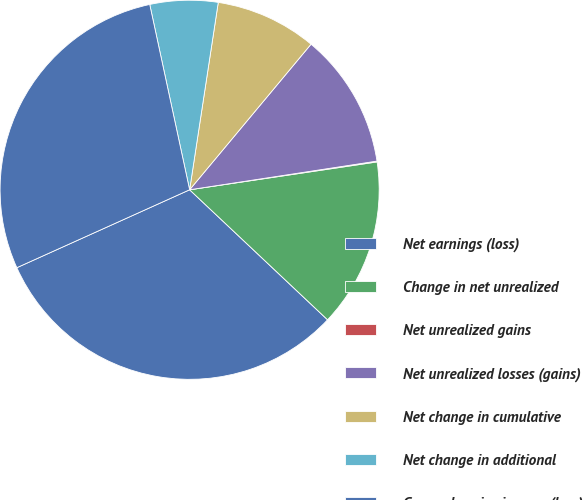Convert chart. <chart><loc_0><loc_0><loc_500><loc_500><pie_chart><fcel>Net earnings (loss)<fcel>Change in net unrealized<fcel>Net unrealized gains<fcel>Net unrealized losses (gains)<fcel>Net change in cumulative<fcel>Net change in additional<fcel>Comprehensive income (loss)<nl><fcel>31.23%<fcel>14.38%<fcel>0.07%<fcel>11.52%<fcel>8.65%<fcel>5.79%<fcel>28.37%<nl></chart> 